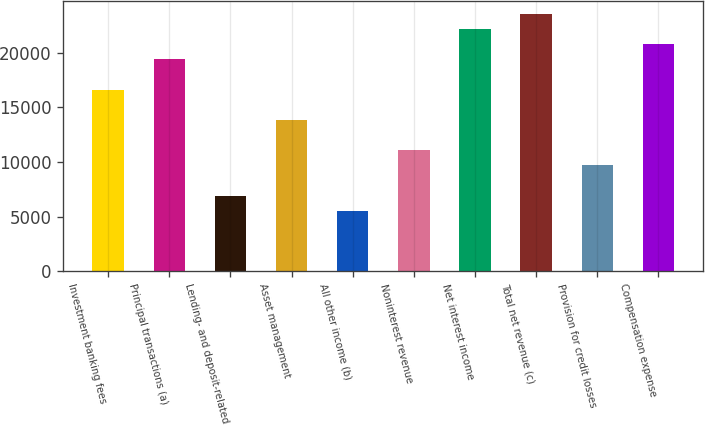<chart> <loc_0><loc_0><loc_500><loc_500><bar_chart><fcel>Investment banking fees<fcel>Principal transactions (a)<fcel>Lending- and deposit-related<fcel>Asset management<fcel>All other income (b)<fcel>Noninterest revenue<fcel>Net interest income<fcel>Total net revenue (c)<fcel>Provision for credit losses<fcel>Compensation expense<nl><fcel>16612.8<fcel>19381.6<fcel>6922.09<fcel>13844<fcel>5537.7<fcel>11075.3<fcel>22150.4<fcel>23534.8<fcel>9690.87<fcel>20766<nl></chart> 